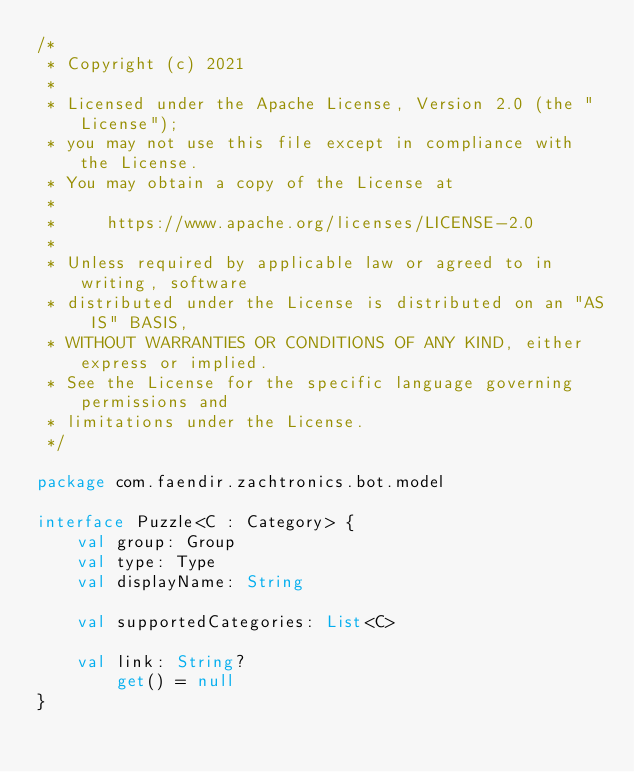<code> <loc_0><loc_0><loc_500><loc_500><_Kotlin_>/*
 * Copyright (c) 2021
 *
 * Licensed under the Apache License, Version 2.0 (the "License");
 * you may not use this file except in compliance with the License.
 * You may obtain a copy of the License at
 *
 *     https://www.apache.org/licenses/LICENSE-2.0
 *
 * Unless required by applicable law or agreed to in writing, software
 * distributed under the License is distributed on an "AS IS" BASIS,
 * WITHOUT WARRANTIES OR CONDITIONS OF ANY KIND, either express or implied.
 * See the License for the specific language governing permissions and
 * limitations under the License.
 */

package com.faendir.zachtronics.bot.model

interface Puzzle<C : Category> {
    val group: Group
    val type: Type
    val displayName: String

    val supportedCategories: List<C>

    val link: String?
        get() = null
}</code> 